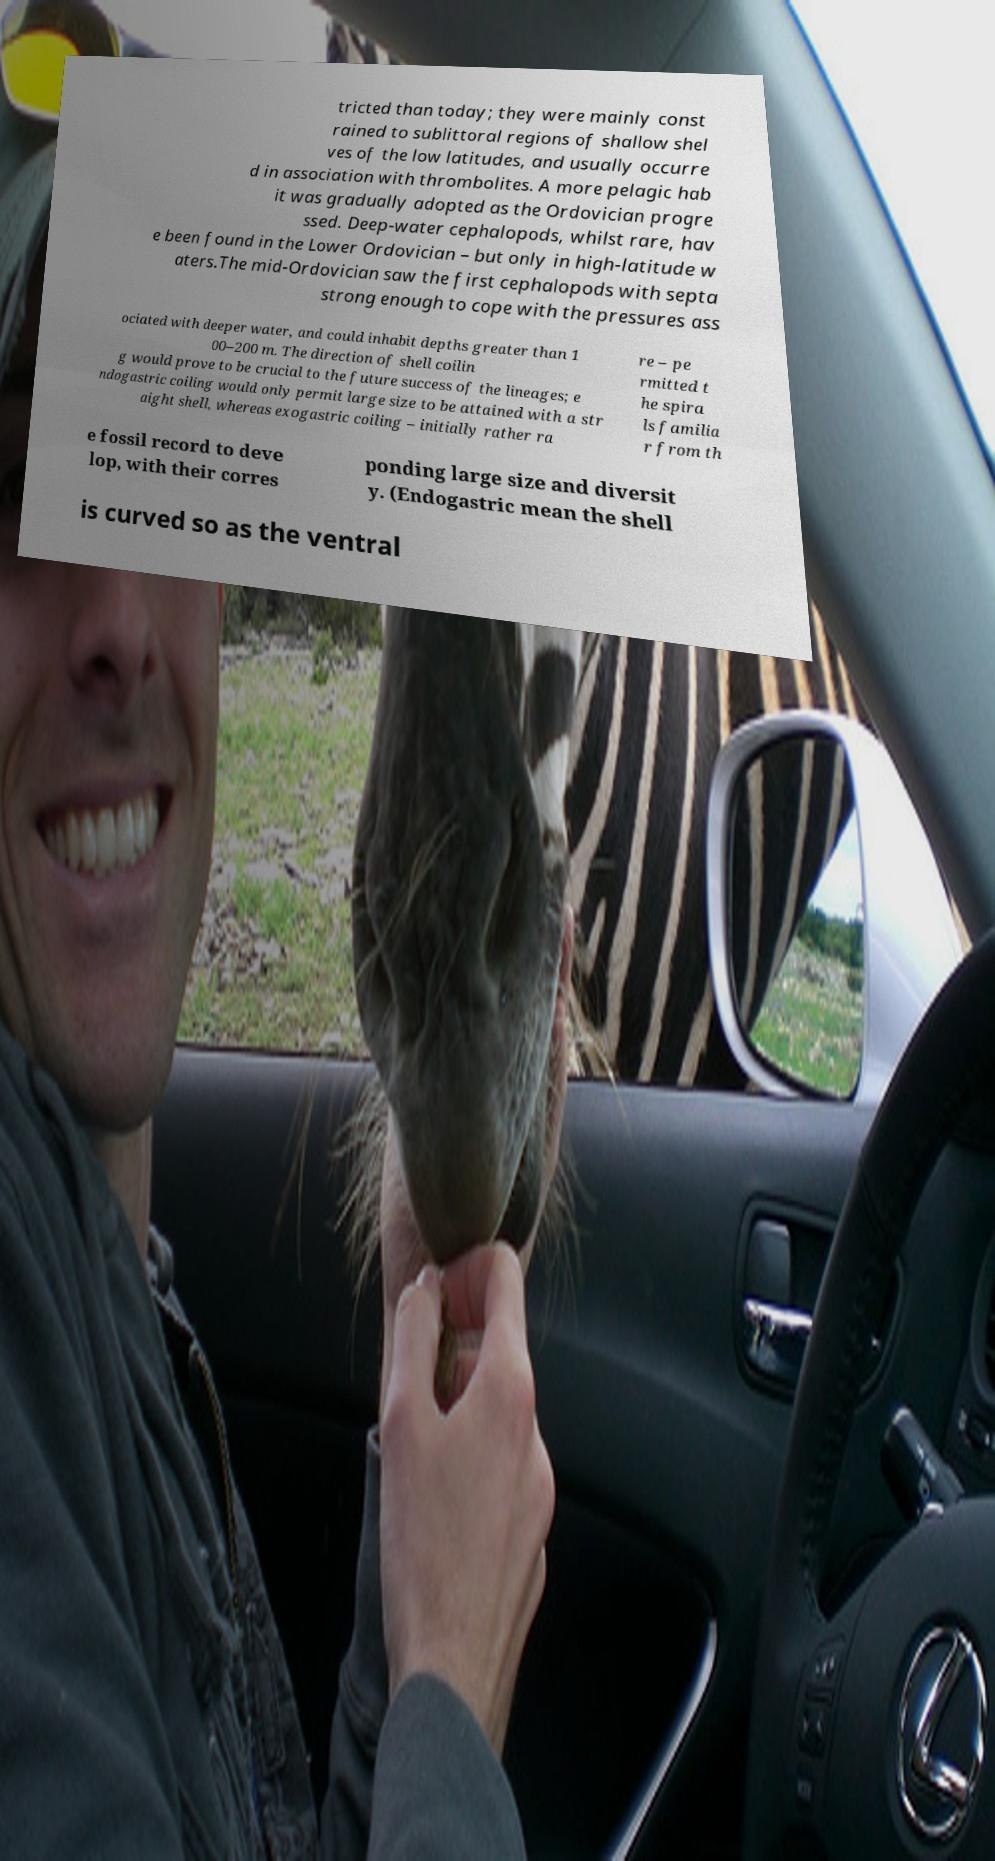There's text embedded in this image that I need extracted. Can you transcribe it verbatim? tricted than today; they were mainly const rained to sublittoral regions of shallow shel ves of the low latitudes, and usually occurre d in association with thrombolites. A more pelagic hab it was gradually adopted as the Ordovician progre ssed. Deep-water cephalopods, whilst rare, hav e been found in the Lower Ordovician – but only in high-latitude w aters.The mid-Ordovician saw the first cephalopods with septa strong enough to cope with the pressures ass ociated with deeper water, and could inhabit depths greater than 1 00–200 m. The direction of shell coilin g would prove to be crucial to the future success of the lineages; e ndogastric coiling would only permit large size to be attained with a str aight shell, whereas exogastric coiling – initially rather ra re – pe rmitted t he spira ls familia r from th e fossil record to deve lop, with their corres ponding large size and diversit y. (Endogastric mean the shell is curved so as the ventral 